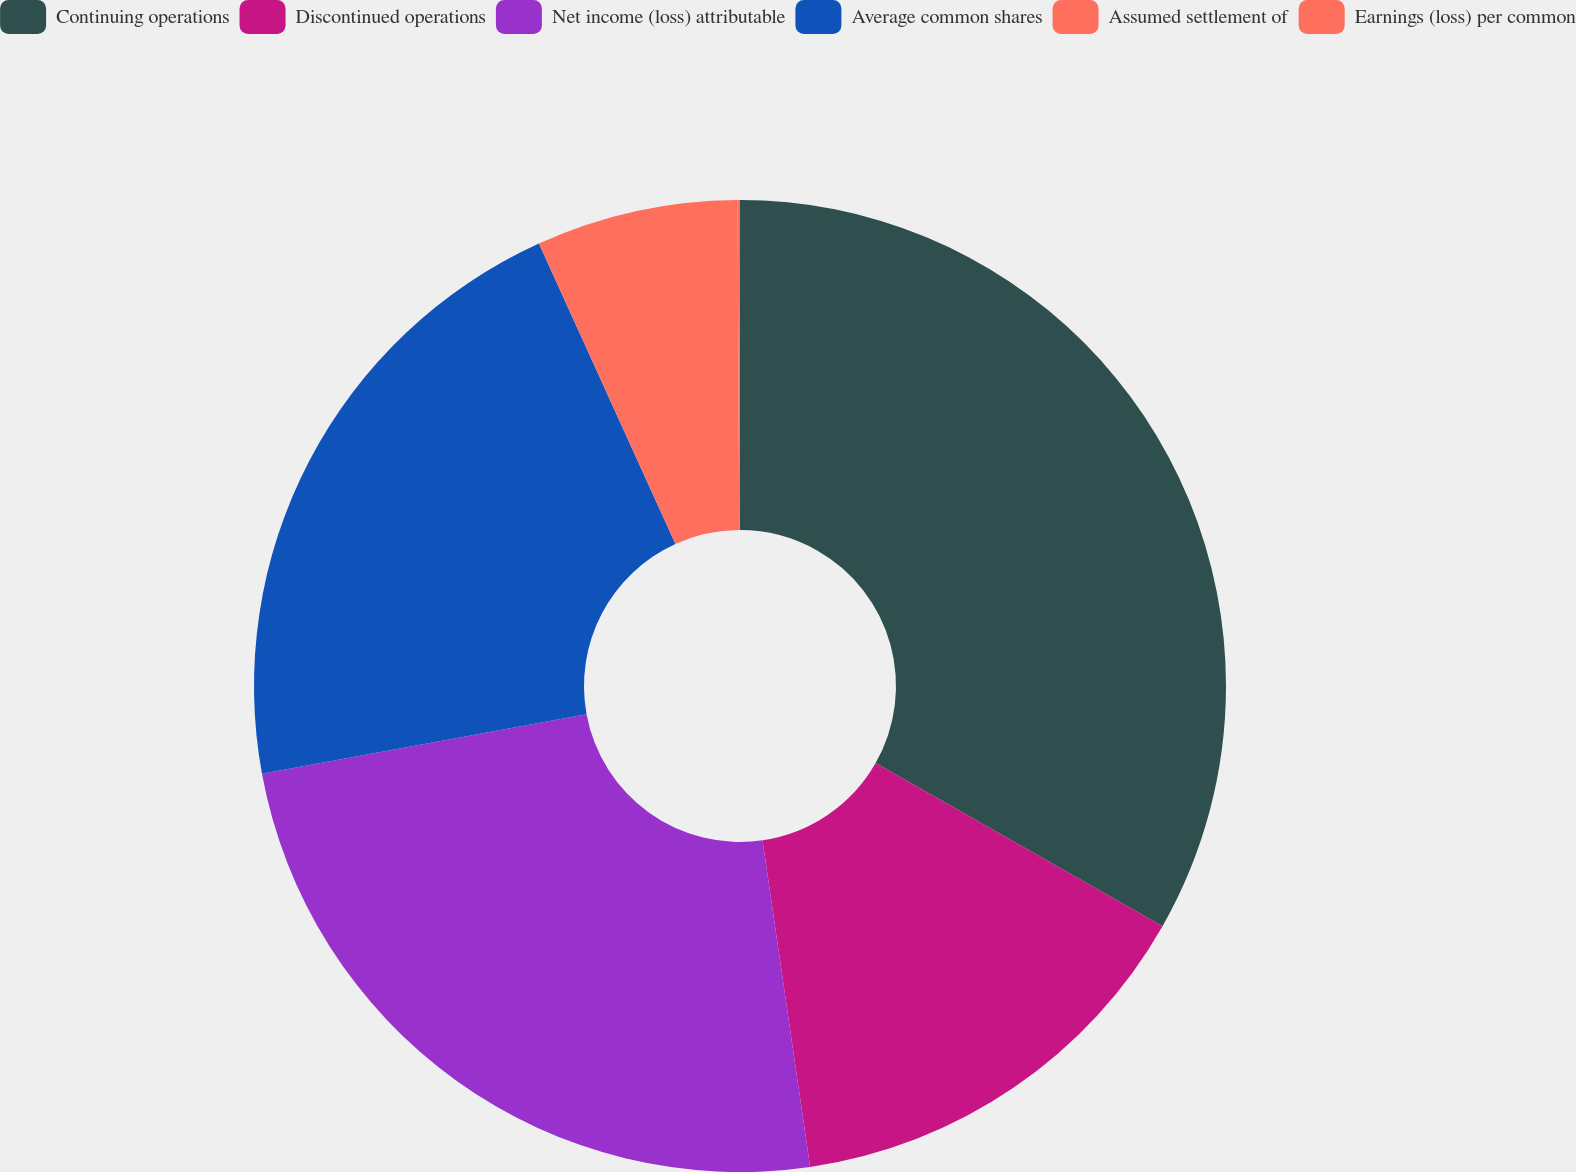Convert chart to OTSL. <chart><loc_0><loc_0><loc_500><loc_500><pie_chart><fcel>Continuing operations<fcel>Discontinued operations<fcel>Net income (loss) attributable<fcel>Average common shares<fcel>Assumed settlement of<fcel>Earnings (loss) per common<nl><fcel>33.23%<fcel>14.47%<fcel>24.42%<fcel>21.1%<fcel>6.71%<fcel>0.08%<nl></chart> 